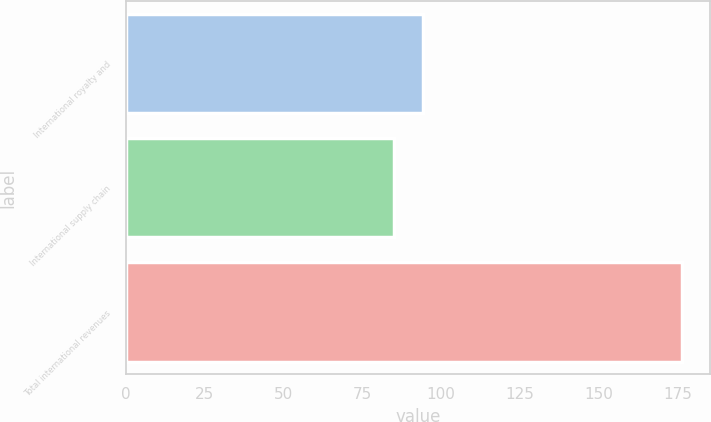Convert chart to OTSL. <chart><loc_0><loc_0><loc_500><loc_500><bar_chart><fcel>International royalty and<fcel>International supply chain<fcel>Total international revenues<nl><fcel>94.23<fcel>85.1<fcel>176.4<nl></chart> 